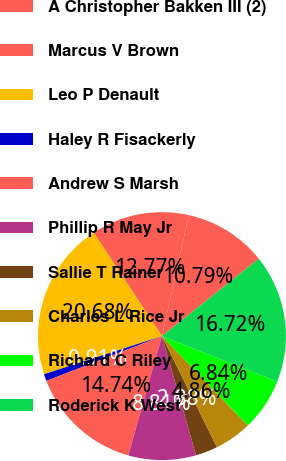Convert chart. <chart><loc_0><loc_0><loc_500><loc_500><pie_chart><fcel>A Christopher Bakken III (2)<fcel>Marcus V Brown<fcel>Leo P Denault<fcel>Haley R Fisackerly<fcel>Andrew S Marsh<fcel>Phillip R May Jr<fcel>Sallie T Rainer<fcel>Charles L Rice Jr<fcel>Richard C Riley<fcel>Roderick K West<nl><fcel>10.79%<fcel>12.77%<fcel>20.68%<fcel>0.91%<fcel>14.74%<fcel>8.81%<fcel>2.88%<fcel>4.86%<fcel>6.84%<fcel>16.72%<nl></chart> 